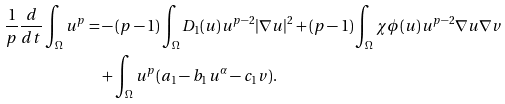Convert formula to latex. <formula><loc_0><loc_0><loc_500><loc_500>\frac { 1 } { p } \frac { d } { d t } \int _ { \Omega } u ^ { p } = & - ( p - 1 ) \int _ { \Omega } D _ { 1 } ( u ) u ^ { p - 2 } | \nabla u | ^ { 2 } + ( p - 1 ) \int _ { \Omega } \chi \phi ( u ) u ^ { p - 2 } \nabla u \nabla v \\ & + \int _ { \Omega } u ^ { p } ( a _ { 1 } - b _ { 1 } u ^ { \alpha } - c _ { 1 } v ) .</formula> 